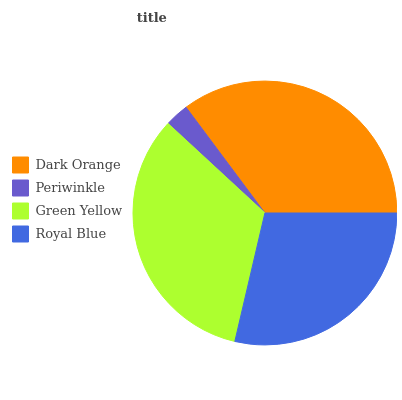Is Periwinkle the minimum?
Answer yes or no. Yes. Is Dark Orange the maximum?
Answer yes or no. Yes. Is Green Yellow the minimum?
Answer yes or no. No. Is Green Yellow the maximum?
Answer yes or no. No. Is Green Yellow greater than Periwinkle?
Answer yes or no. Yes. Is Periwinkle less than Green Yellow?
Answer yes or no. Yes. Is Periwinkle greater than Green Yellow?
Answer yes or no. No. Is Green Yellow less than Periwinkle?
Answer yes or no. No. Is Green Yellow the high median?
Answer yes or no. Yes. Is Royal Blue the low median?
Answer yes or no. Yes. Is Periwinkle the high median?
Answer yes or no. No. Is Periwinkle the low median?
Answer yes or no. No. 